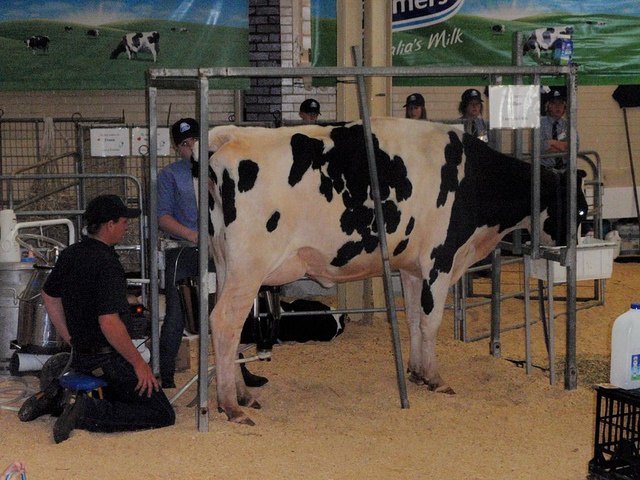Describe the objects in this image and their specific colors. I can see cow in darkblue, black, and gray tones, people in darkblue, black, maroon, brown, and navy tones, people in darkblue, black, navy, and gray tones, people in darkblue, black, gray, and maroon tones, and bottle in darkblue, darkgray, gray, and navy tones in this image. 